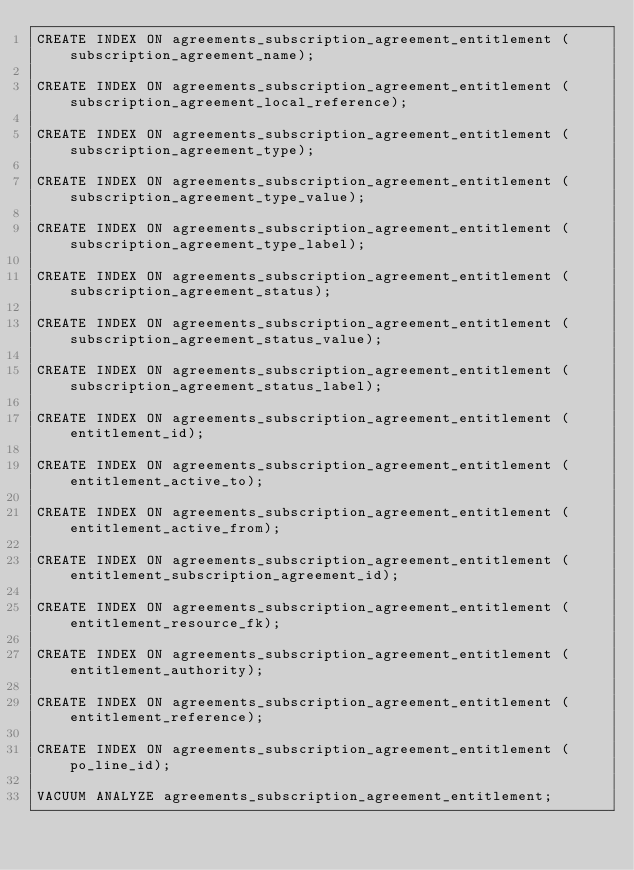<code> <loc_0><loc_0><loc_500><loc_500><_SQL_>CREATE INDEX ON agreements_subscription_agreement_entitlement (subscription_agreement_name);

CREATE INDEX ON agreements_subscription_agreement_entitlement (subscription_agreement_local_reference);

CREATE INDEX ON agreements_subscription_agreement_entitlement (subscription_agreement_type);

CREATE INDEX ON agreements_subscription_agreement_entitlement (subscription_agreement_type_value);

CREATE INDEX ON agreements_subscription_agreement_entitlement (subscription_agreement_type_label);

CREATE INDEX ON agreements_subscription_agreement_entitlement (subscription_agreement_status);

CREATE INDEX ON agreements_subscription_agreement_entitlement (subscription_agreement_status_value);

CREATE INDEX ON agreements_subscription_agreement_entitlement (subscription_agreement_status_label);

CREATE INDEX ON agreements_subscription_agreement_entitlement (entitlement_id);

CREATE INDEX ON agreements_subscription_agreement_entitlement (entitlement_active_to);

CREATE INDEX ON agreements_subscription_agreement_entitlement (entitlement_active_from);

CREATE INDEX ON agreements_subscription_agreement_entitlement (entitlement_subscription_agreement_id);

CREATE INDEX ON agreements_subscription_agreement_entitlement (entitlement_resource_fk);

CREATE INDEX ON agreements_subscription_agreement_entitlement (entitlement_authority);

CREATE INDEX ON agreements_subscription_agreement_entitlement (entitlement_reference);

CREATE INDEX ON agreements_subscription_agreement_entitlement (po_line_id);

VACUUM ANALYZE agreements_subscription_agreement_entitlement;
</code> 